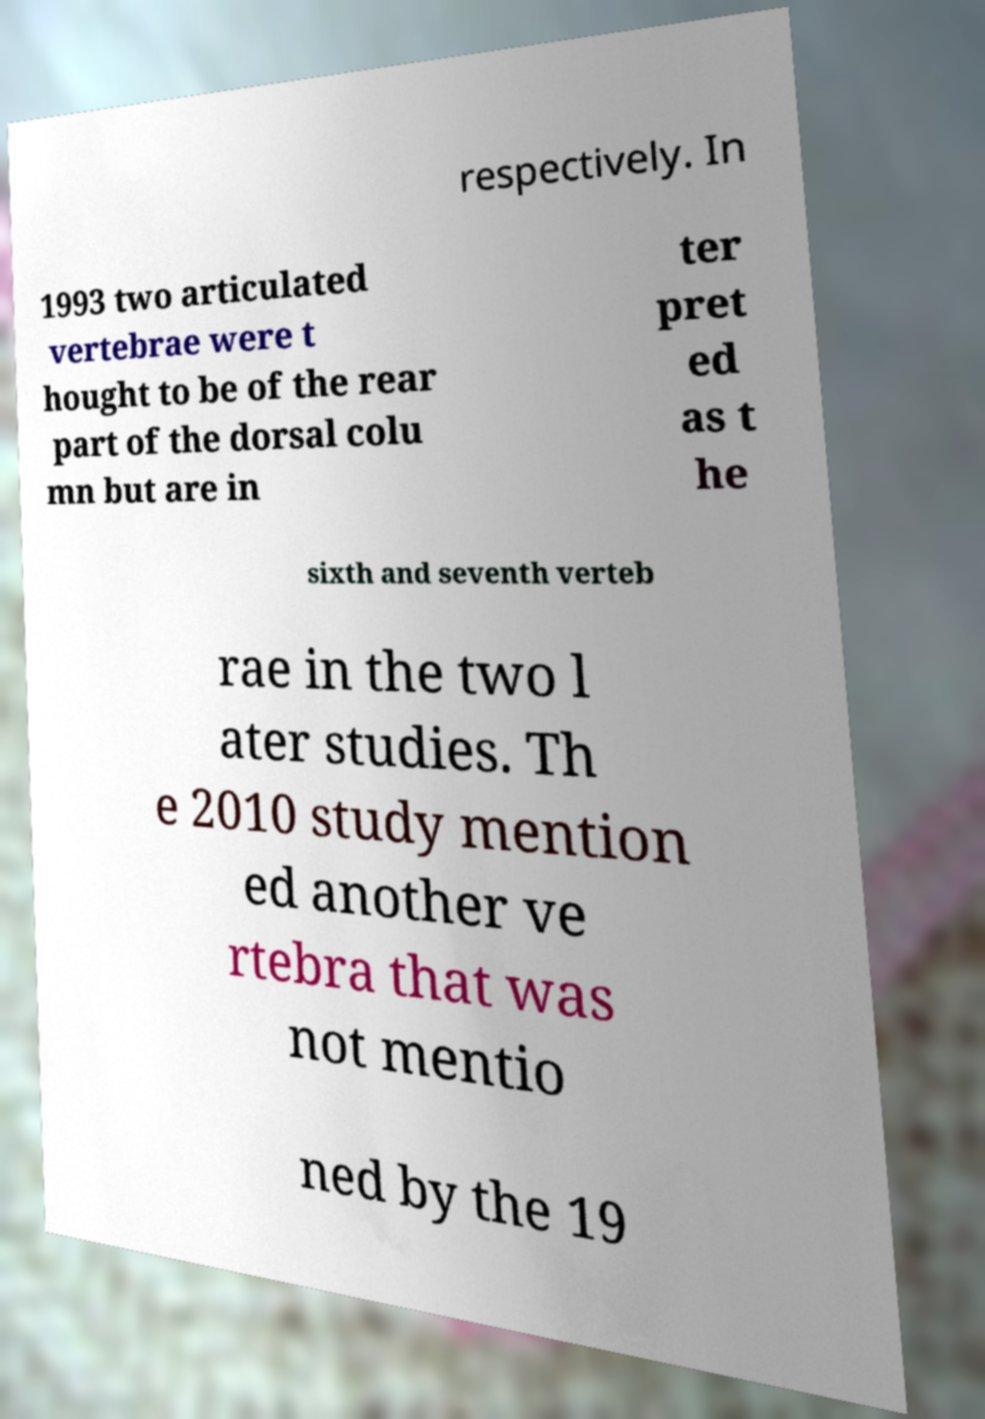Could you assist in decoding the text presented in this image and type it out clearly? respectively. In 1993 two articulated vertebrae were t hought to be of the rear part of the dorsal colu mn but are in ter pret ed as t he sixth and seventh verteb rae in the two l ater studies. Th e 2010 study mention ed another ve rtebra that was not mentio ned by the 19 